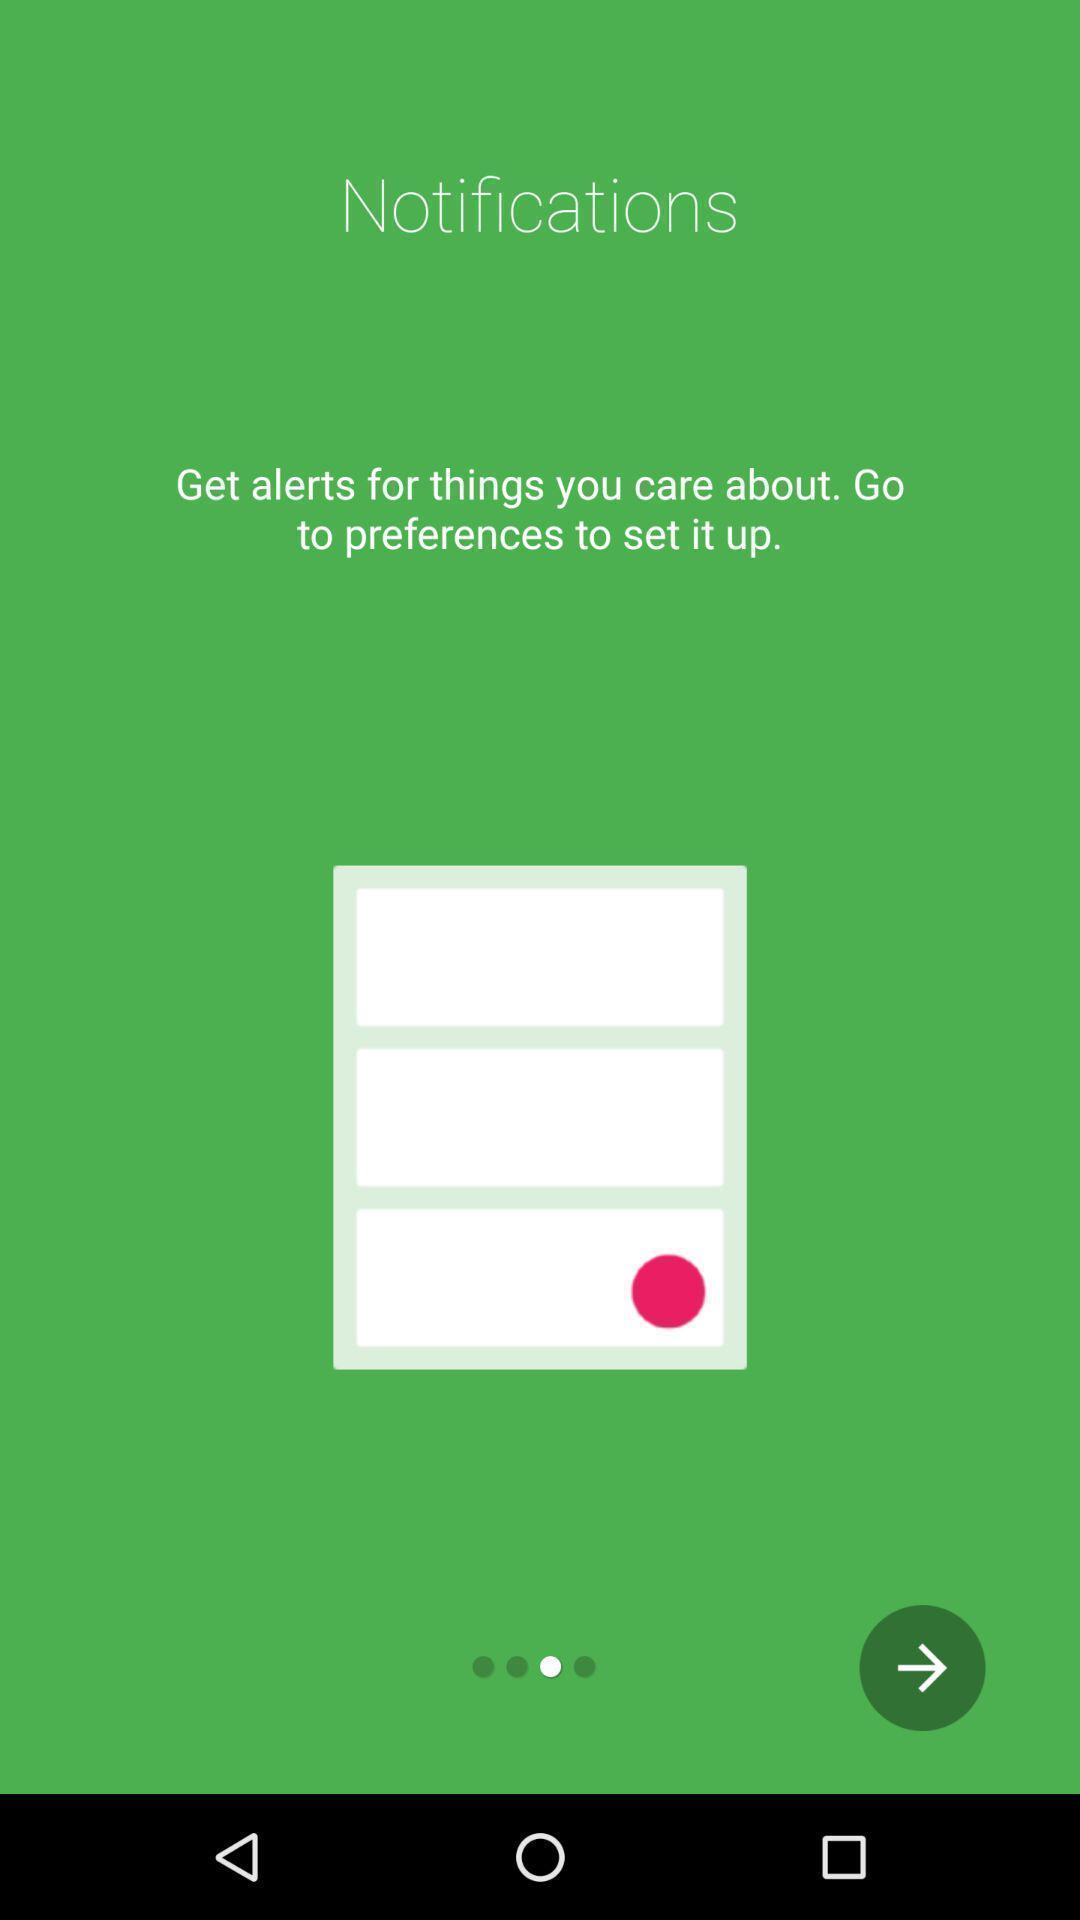What is the overall content of this screenshot? Screen shows notifications. 